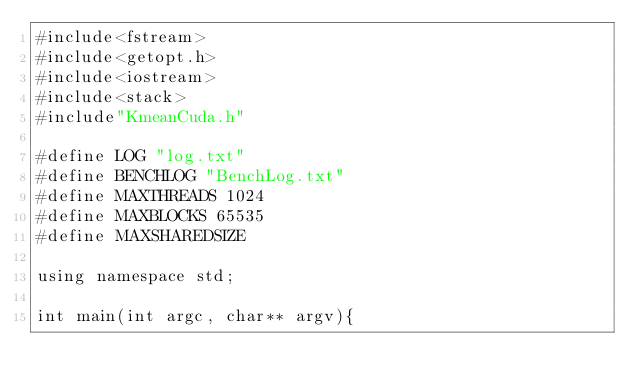<code> <loc_0><loc_0><loc_500><loc_500><_Cuda_>#include<fstream>
#include<getopt.h>
#include<iostream>
#include<stack>
#include"KmeanCuda.h"

#define LOG "log.txt"
#define BENCHLOG "BenchLog.txt"
#define MAXTHREADS 1024
#define MAXBLOCKS 65535
#define MAXSHAREDSIZE 

using namespace std;

int main(int argc, char** argv){
  </code> 